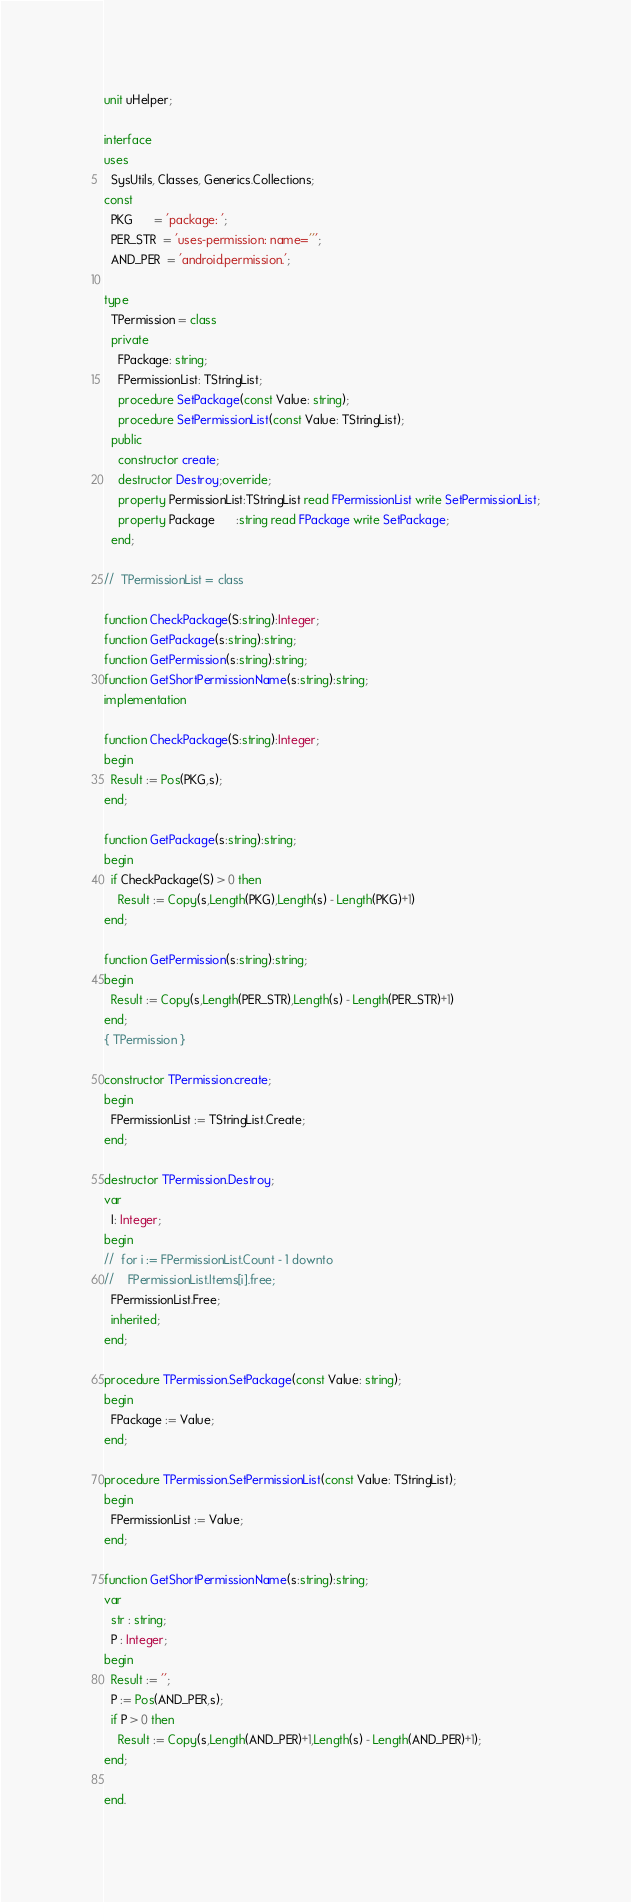Convert code to text. <code><loc_0><loc_0><loc_500><loc_500><_Pascal_>unit uHelper;

interface
uses
  SysUtils, Classes, Generics.Collections;
const
  PKG      = 'package: ';
  PER_STR  = 'uses-permission: name=''';
  AND_PER  = 'android.permission.';

type
  TPermission = class
  private
    FPackage: string;
    FPermissionList: TStringList;
    procedure SetPackage(const Value: string);
    procedure SetPermissionList(const Value: TStringList);
  public
    constructor create;
    destructor Destroy;override;
    property PermissionList:TStringList read FPermissionList write SetPermissionList;
    property Package      :string read FPackage write SetPackage;
  end;

//  TPermissionList = class

function CheckPackage(S:string):Integer;
function GetPackage(s:string):string;
function GetPermission(s:string):string;
function GetShortPermissionName(s:string):string;
implementation

function CheckPackage(S:string):Integer;
begin
  Result := Pos(PKG,s);
end;

function GetPackage(s:string):string;
begin
  if CheckPackage(S) > 0 then
    Result := Copy(s,Length(PKG),Length(s) - Length(PKG)+1)
end;

function GetPermission(s:string):string;
begin
  Result := Copy(s,Length(PER_STR),Length(s) - Length(PER_STR)+1)
end;
{ TPermission }

constructor TPermission.create;
begin
  FPermissionList := TStringList.Create;
end;

destructor TPermission.Destroy;
var
  I: Integer;
begin
//  for i := FPermissionList.Count - 1 downto
//    FPermissionList.Items[i].free;
  FPermissionList.Free;
  inherited;
end;

procedure TPermission.SetPackage(const Value: string);
begin
  FPackage := Value;
end;

procedure TPermission.SetPermissionList(const Value: TStringList);
begin
  FPermissionList := Value;
end;

function GetShortPermissionName(s:string):string;
var
  str : string;
  P : Integer;
begin
  Result := '';
  P := Pos(AND_PER,s);
  if P > 0 then
    Result := Copy(s,Length(AND_PER)+1,Length(s) - Length(AND_PER)+1);
end;

end.
</code> 